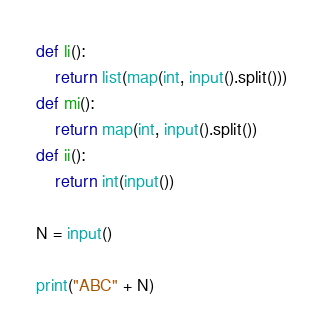Convert code to text. <code><loc_0><loc_0><loc_500><loc_500><_Python_>def li():
    return list(map(int, input().split()))
def mi():
    return map(int, input().split())
def ii():
    return int(input())

N = input()

print("ABC" + N)</code> 